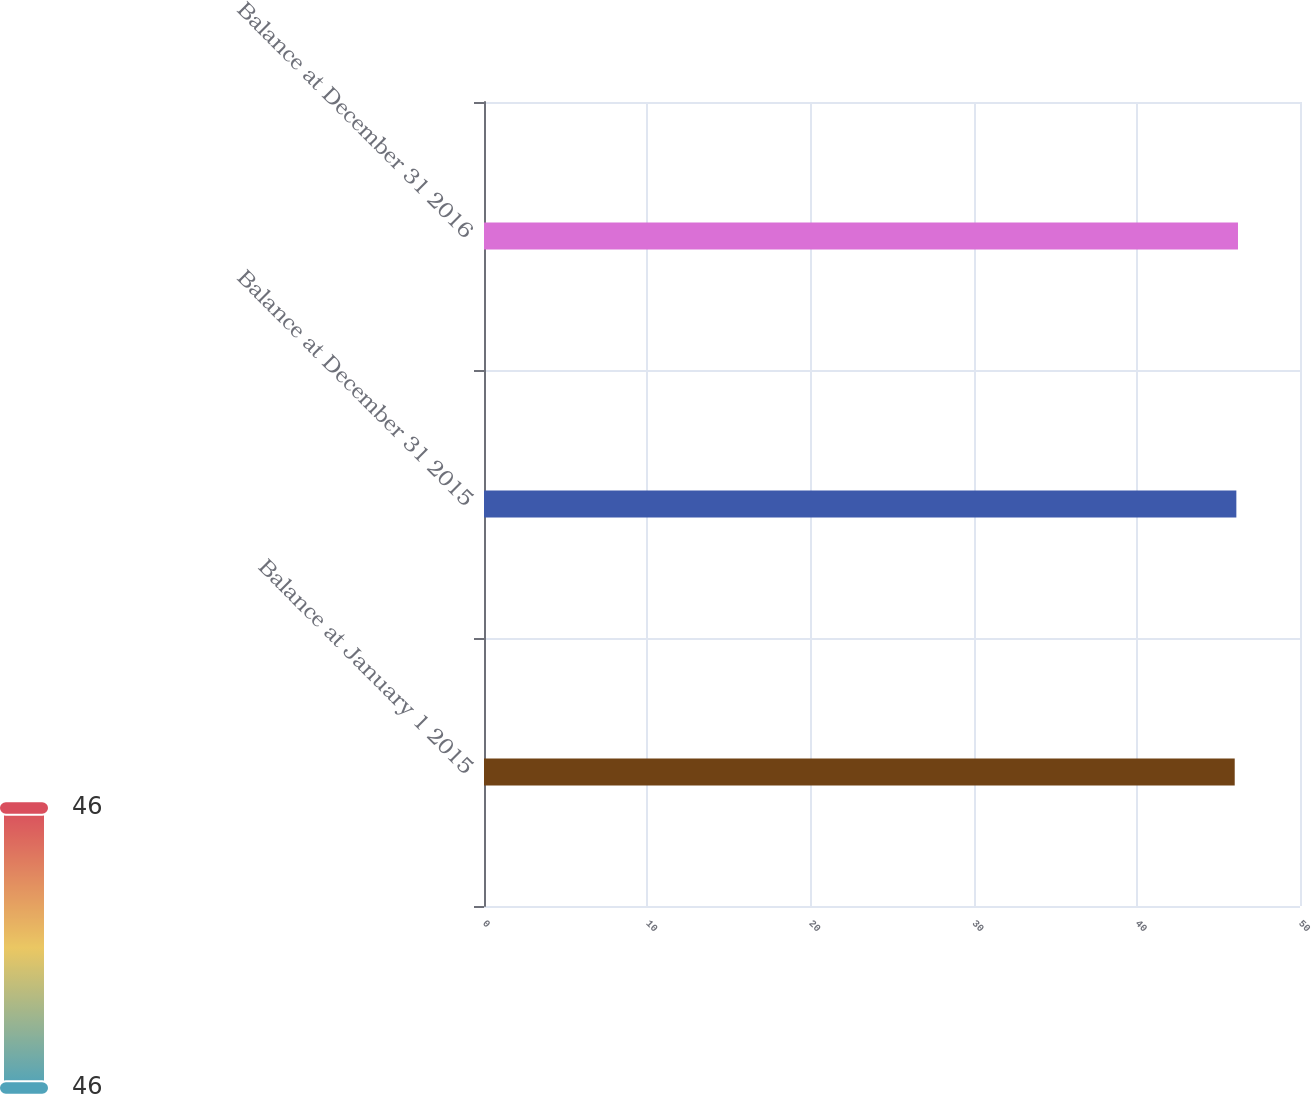<chart> <loc_0><loc_0><loc_500><loc_500><bar_chart><fcel>Balance at January 1 2015<fcel>Balance at December 31 2015<fcel>Balance at December 31 2016<nl><fcel>46<fcel>46.1<fcel>46.2<nl></chart> 